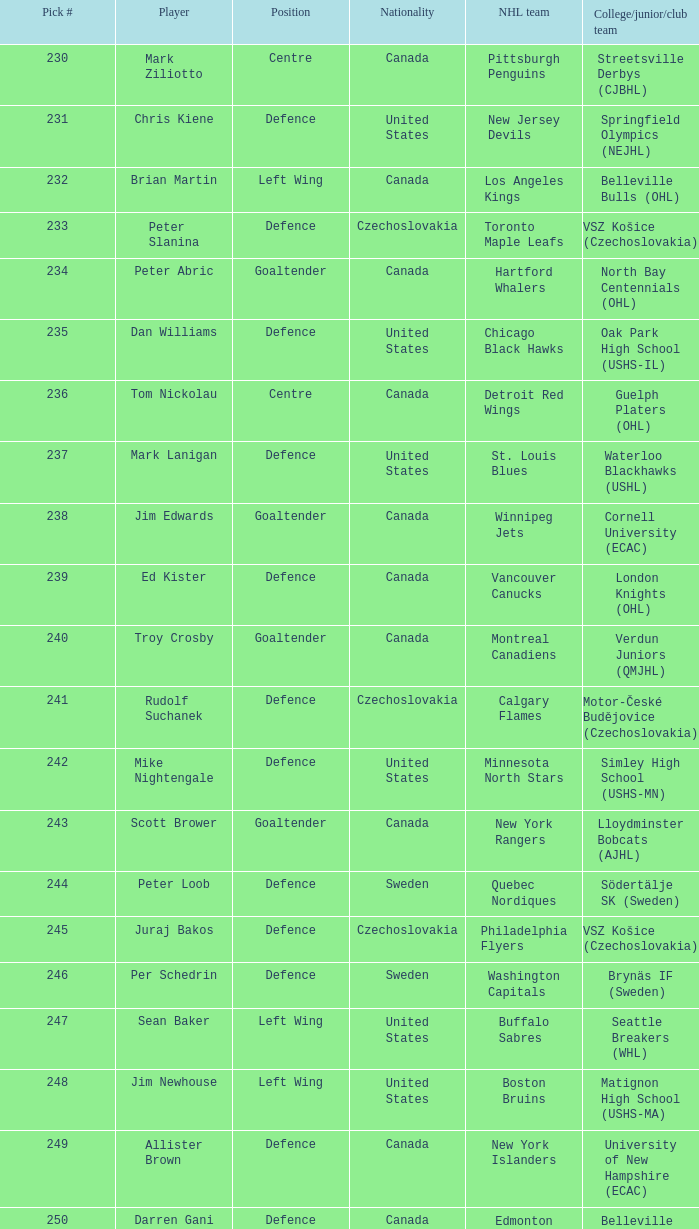What position does allister brown play. Defence. Parse the full table. {'header': ['Pick #', 'Player', 'Position', 'Nationality', 'NHL team', 'College/junior/club team'], 'rows': [['230', 'Mark Ziliotto', 'Centre', 'Canada', 'Pittsburgh Penguins', 'Streetsville Derbys (CJBHL)'], ['231', 'Chris Kiene', 'Defence', 'United States', 'New Jersey Devils', 'Springfield Olympics (NEJHL)'], ['232', 'Brian Martin', 'Left Wing', 'Canada', 'Los Angeles Kings', 'Belleville Bulls (OHL)'], ['233', 'Peter Slanina', 'Defence', 'Czechoslovakia', 'Toronto Maple Leafs', 'VSZ Košice (Czechoslovakia)'], ['234', 'Peter Abric', 'Goaltender', 'Canada', 'Hartford Whalers', 'North Bay Centennials (OHL)'], ['235', 'Dan Williams', 'Defence', 'United States', 'Chicago Black Hawks', 'Oak Park High School (USHS-IL)'], ['236', 'Tom Nickolau', 'Centre', 'Canada', 'Detroit Red Wings', 'Guelph Platers (OHL)'], ['237', 'Mark Lanigan', 'Defence', 'United States', 'St. Louis Blues', 'Waterloo Blackhawks (USHL)'], ['238', 'Jim Edwards', 'Goaltender', 'Canada', 'Winnipeg Jets', 'Cornell University (ECAC)'], ['239', 'Ed Kister', 'Defence', 'Canada', 'Vancouver Canucks', 'London Knights (OHL)'], ['240', 'Troy Crosby', 'Goaltender', 'Canada', 'Montreal Canadiens', 'Verdun Juniors (QMJHL)'], ['241', 'Rudolf Suchanek', 'Defence', 'Czechoslovakia', 'Calgary Flames', 'Motor-České Budějovice (Czechoslovakia)'], ['242', 'Mike Nightengale', 'Defence', 'United States', 'Minnesota North Stars', 'Simley High School (USHS-MN)'], ['243', 'Scott Brower', 'Goaltender', 'Canada', 'New York Rangers', 'Lloydminster Bobcats (AJHL)'], ['244', 'Peter Loob', 'Defence', 'Sweden', 'Quebec Nordiques', 'Södertälje SK (Sweden)'], ['245', 'Juraj Bakos', 'Defence', 'Czechoslovakia', 'Philadelphia Flyers', 'VSZ Košice (Czechoslovakia)'], ['246', 'Per Schedrin', 'Defence', 'Sweden', 'Washington Capitals', 'Brynäs IF (Sweden)'], ['247', 'Sean Baker', 'Left Wing', 'United States', 'Buffalo Sabres', 'Seattle Breakers (WHL)'], ['248', 'Jim Newhouse', 'Left Wing', 'United States', 'Boston Bruins', 'Matignon High School (USHS-MA)'], ['249', 'Allister Brown', 'Defence', 'Canada', 'New York Islanders', 'University of New Hampshire (ECAC)'], ['250', 'Darren Gani', 'Defence', 'Canada', 'Edmonton Oilers', 'Belleville Bulls (OHL)']]} 